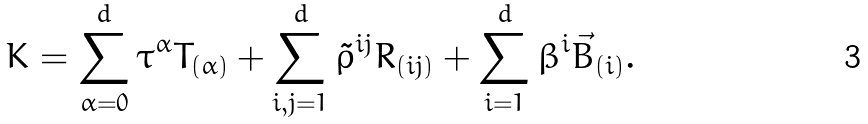Convert formula to latex. <formula><loc_0><loc_0><loc_500><loc_500>K = \sum _ { \alpha = 0 } ^ { d } \tau ^ { \alpha } T _ { ( \alpha ) } + \sum _ { \substack { i , j = 1 } } ^ { d } \tilde { \rho } ^ { i j } R _ { ( i j ) } + \sum _ { i = 1 } ^ { d } \beta ^ { i } \vec { B } _ { ( i ) } .</formula> 